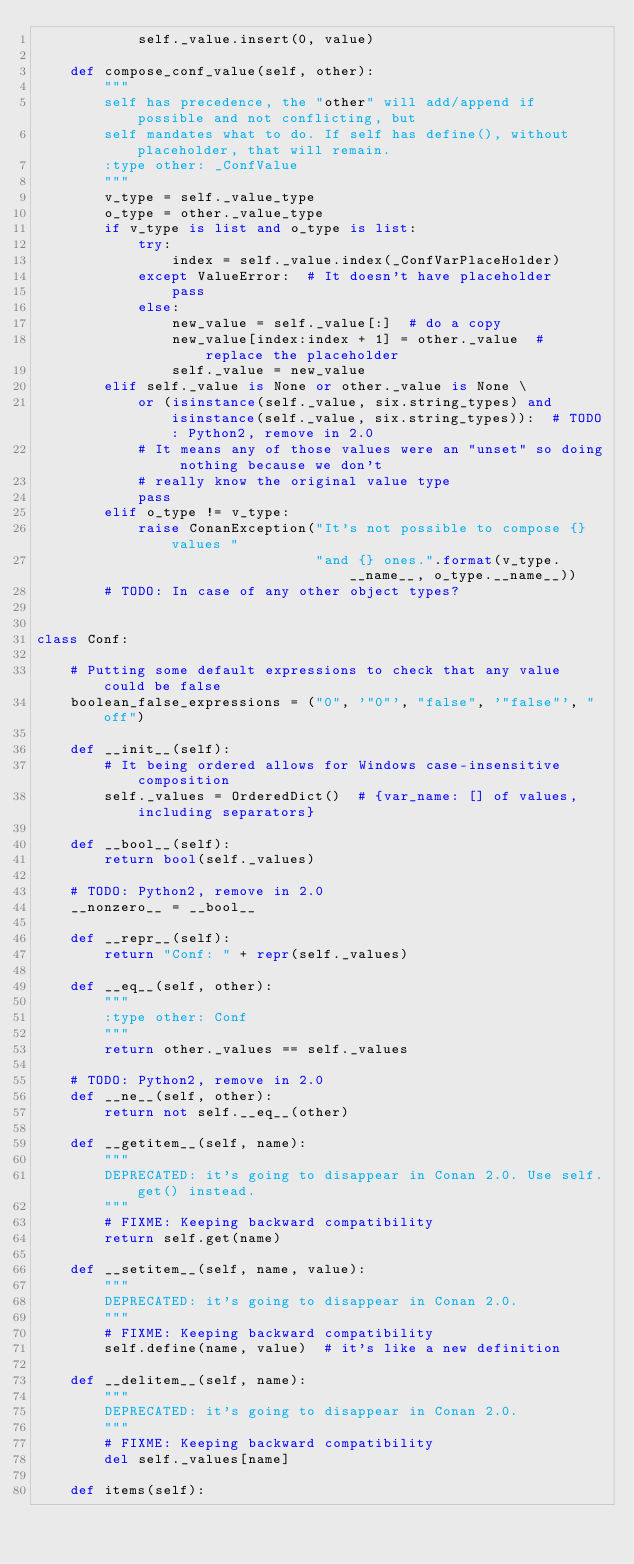<code> <loc_0><loc_0><loc_500><loc_500><_Python_>            self._value.insert(0, value)

    def compose_conf_value(self, other):
        """
        self has precedence, the "other" will add/append if possible and not conflicting, but
        self mandates what to do. If self has define(), without placeholder, that will remain.
        :type other: _ConfValue
        """
        v_type = self._value_type
        o_type = other._value_type
        if v_type is list and o_type is list:
            try:
                index = self._value.index(_ConfVarPlaceHolder)
            except ValueError:  # It doesn't have placeholder
                pass
            else:
                new_value = self._value[:]  # do a copy
                new_value[index:index + 1] = other._value  # replace the placeholder
                self._value = new_value
        elif self._value is None or other._value is None \
            or (isinstance(self._value, six.string_types) and isinstance(self._value, six.string_types)):  # TODO: Python2, remove in 2.0
            # It means any of those values were an "unset" so doing nothing because we don't
            # really know the original value type
            pass
        elif o_type != v_type:
            raise ConanException("It's not possible to compose {} values "
                                 "and {} ones.".format(v_type.__name__, o_type.__name__))
        # TODO: In case of any other object types?


class Conf:

    # Putting some default expressions to check that any value could be false
    boolean_false_expressions = ("0", '"0"', "false", '"false"', "off")

    def __init__(self):
        # It being ordered allows for Windows case-insensitive composition
        self._values = OrderedDict()  # {var_name: [] of values, including separators}

    def __bool__(self):
        return bool(self._values)

    # TODO: Python2, remove in 2.0
    __nonzero__ = __bool__

    def __repr__(self):
        return "Conf: " + repr(self._values)

    def __eq__(self, other):
        """
        :type other: Conf
        """
        return other._values == self._values

    # TODO: Python2, remove in 2.0
    def __ne__(self, other):
        return not self.__eq__(other)

    def __getitem__(self, name):
        """
        DEPRECATED: it's going to disappear in Conan 2.0. Use self.get() instead.
        """
        # FIXME: Keeping backward compatibility
        return self.get(name)

    def __setitem__(self, name, value):
        """
        DEPRECATED: it's going to disappear in Conan 2.0.
        """
        # FIXME: Keeping backward compatibility
        self.define(name, value)  # it's like a new definition

    def __delitem__(self, name):
        """
        DEPRECATED: it's going to disappear in Conan 2.0.
        """
        # FIXME: Keeping backward compatibility
        del self._values[name]

    def items(self):</code> 